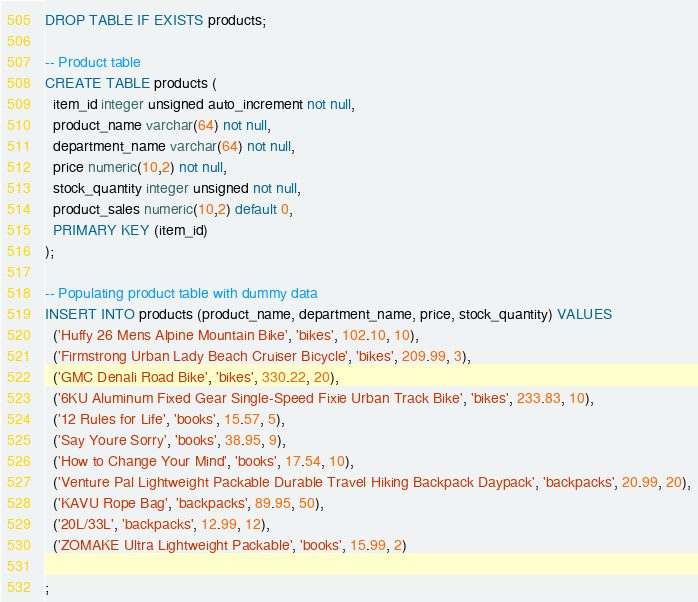Convert code to text. <code><loc_0><loc_0><loc_500><loc_500><_SQL_>DROP TABLE IF EXISTS products;

-- Product table
CREATE TABLE products (
  item_id integer unsigned auto_increment not null,
  product_name varchar(64) not null,
  department_name varchar(64) not null,
  price numeric(10,2) not null,
  stock_quantity integer unsigned not null,
  product_sales numeric(10,2) default 0,
  PRIMARY KEY (item_id)
);

-- Populating product table with dummy data
INSERT INTO products (product_name, department_name, price, stock_quantity) VALUES
  ('Huffy 26 Mens Alpine Mountain Bike', 'bikes', 102.10, 10),
  ('Firmstrong Urban Lady Beach Cruiser Bicycle', 'bikes', 209.99, 3),
  ('GMC Denali Road Bike', 'bikes', 330.22, 20),
  ('6KU Aluminum Fixed Gear Single-Speed Fixie Urban Track Bike', 'bikes', 233.83, 10),
  ('12 Rules for Life', 'books', 15.57, 5),
  ('Say Youre Sorry', 'books', 38.95, 9),
  ('How to Change Your Mind', 'books', 17.54, 10),
  ('Venture Pal Lightweight Packable Durable Travel Hiking Backpack Daypack', 'backpacks', 20.99, 20),
  ('KAVU Rope Bag', 'backpacks', 89.95, 50),
  ('20L/33L', 'backpacks', 12.99, 12),
  ('ZOMAKE Ultra Lightweight Packable', 'books', 15.99, 2)

;
</code> 